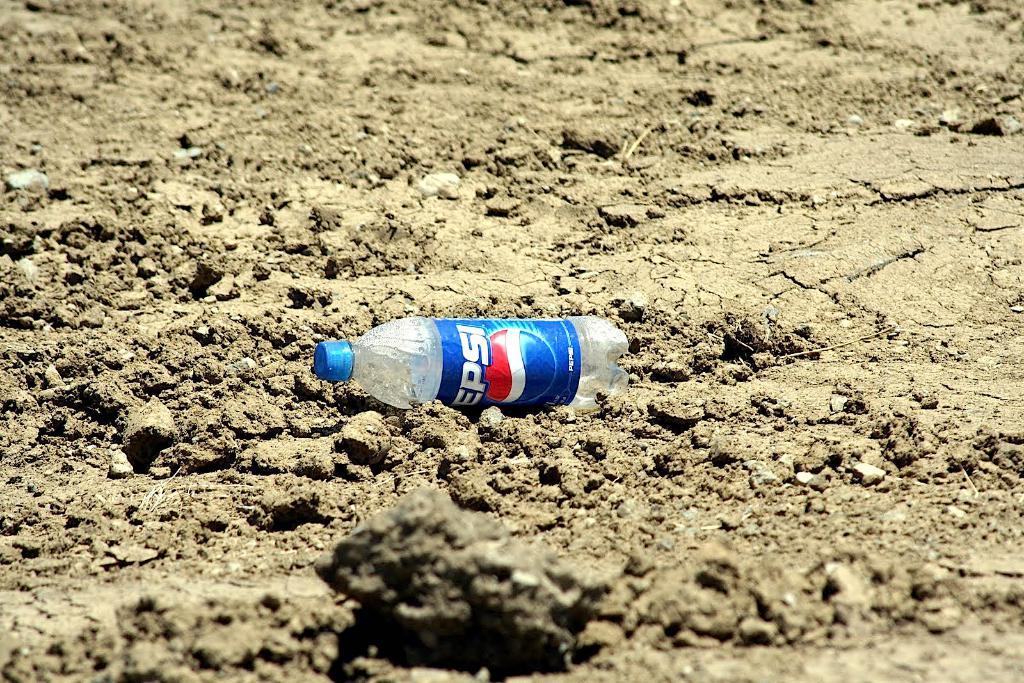Provide a one-sentence caption for the provided image. An empty bottle of Pepsi is laying on the ground. 